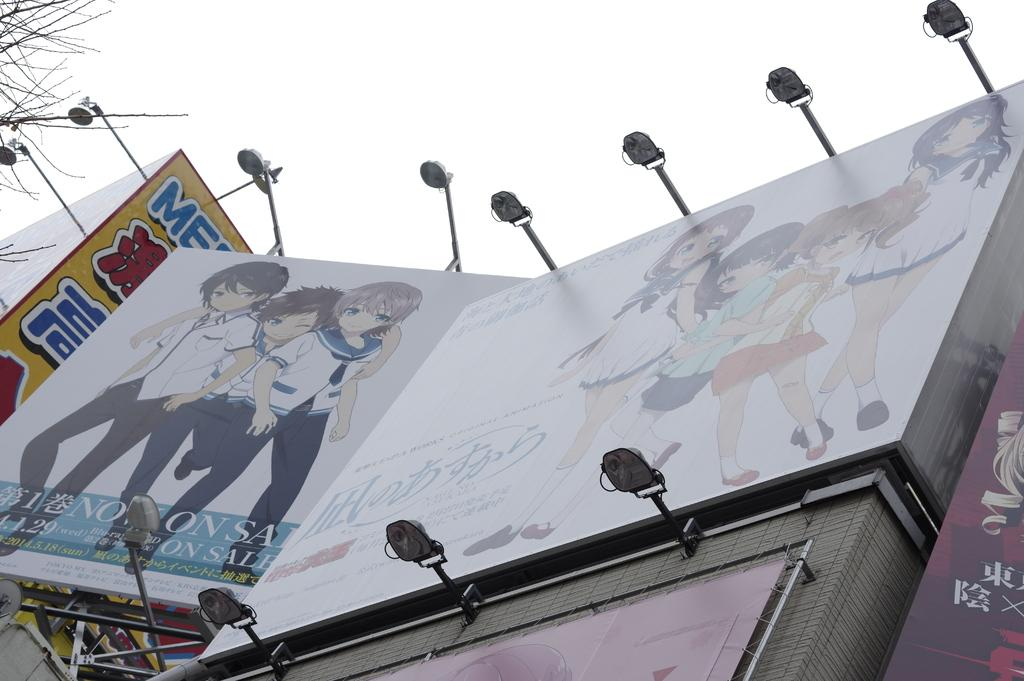What type of signage is present in the image? There are hoardings in the image. What else can be seen in the image besides the hoardings? There are lights visible in the image. What can be seen in the background of the image? The sky is visible in the background of the image. What type of jewel is being advertised on the hoardings in the image? There is no jewel being advertised on the hoardings in the image; the hoardings contain other types of advertisements or information. 